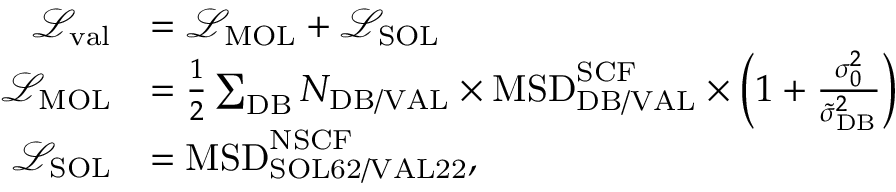Convert formula to latex. <formula><loc_0><loc_0><loc_500><loc_500>\begin{array} { r l } { \mathcal { L } _ { v a l } } & { = \mathcal { L } _ { M O L } + \mathcal { L } _ { S O L } } \\ { \mathcal { L } _ { M O L } } & { = \frac { 1 } { 2 } \sum _ { D B } N _ { D B / V A L } \times M S D _ { D B / V A L } ^ { S C F } \times \left ( 1 + \frac { \sigma _ { 0 } ^ { 2 } } { \tilde { \sigma } _ { D B } ^ { 2 } } \right ) } \\ { \mathcal { L } _ { S O L } } & { = M S D _ { S O L 6 2 / V A L 2 2 } ^ { N S C F } , } \end{array}</formula> 